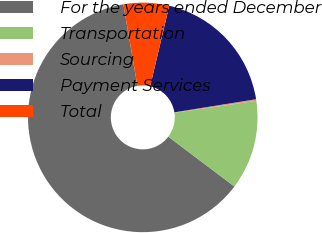Convert chart. <chart><loc_0><loc_0><loc_500><loc_500><pie_chart><fcel>For the years ended December<fcel>Transportation<fcel>Sourcing<fcel>Payment Services<fcel>Total<nl><fcel>62.01%<fcel>12.59%<fcel>0.23%<fcel>18.76%<fcel>6.41%<nl></chart> 